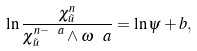Convert formula to latex. <formula><loc_0><loc_0><loc_500><loc_500>\ln \frac { \chi _ { \tilde { u } } ^ { n } } { \chi _ { \tilde { u } } ^ { n - \ a } \wedge \omega ^ { \ } a } = \ln \psi + b ,</formula> 